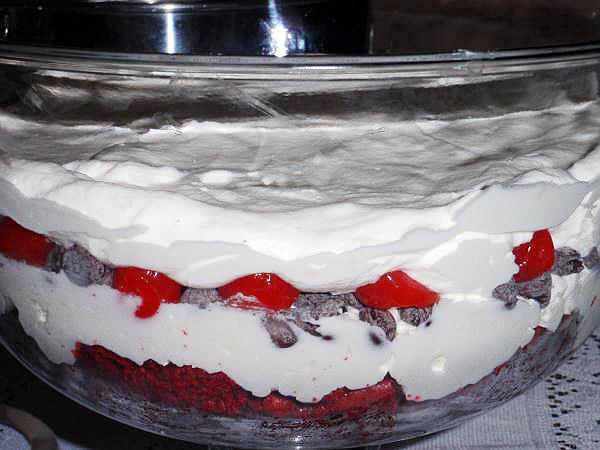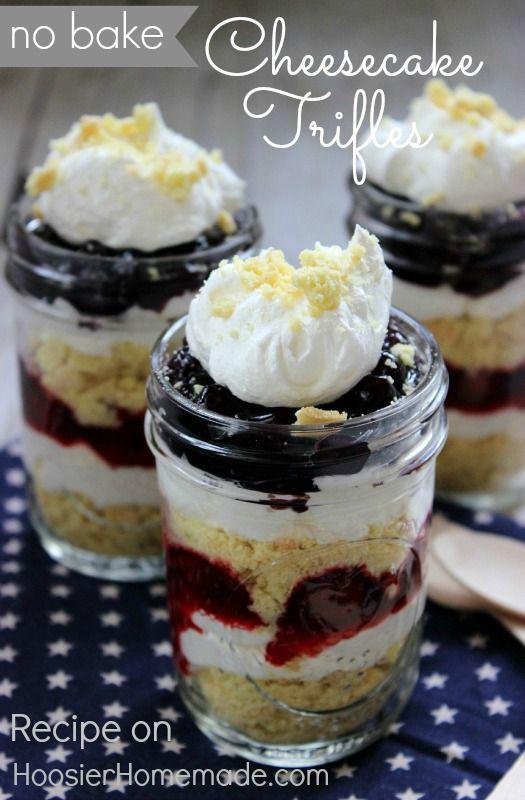The first image is the image on the left, the second image is the image on the right. Considering the images on both sides, is "One image shows three servings of layered dessert that are not displayed in one horizontal row." valid? Answer yes or no. Yes. The first image is the image on the left, the second image is the image on the right. For the images displayed, is the sentence "Two large trifle desserts are made in clear bowls with alernating cake and creamy layers, ending with a garnished creamy top." factually correct? Answer yes or no. No. 